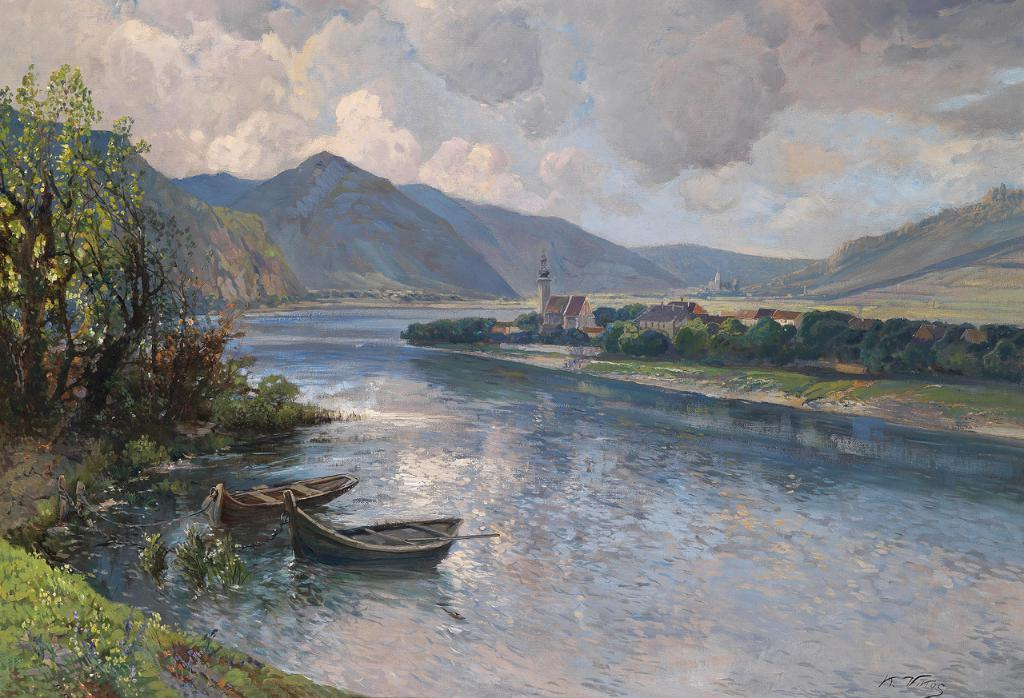What is the main subject of the image? The main subject of the image is a painting. What type of stone can be seen in the painting? There is no stone present in the painting, as the image only features a painting. 